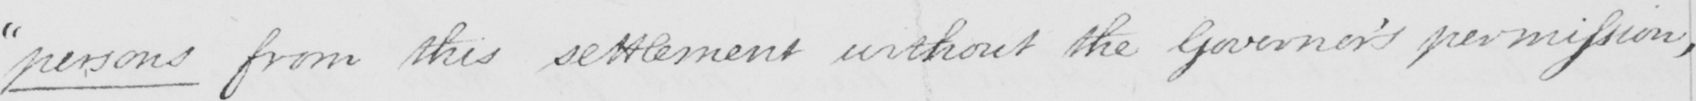Please provide the text content of this handwritten line. " persons from this settlement without the Governor ' s permission ; 